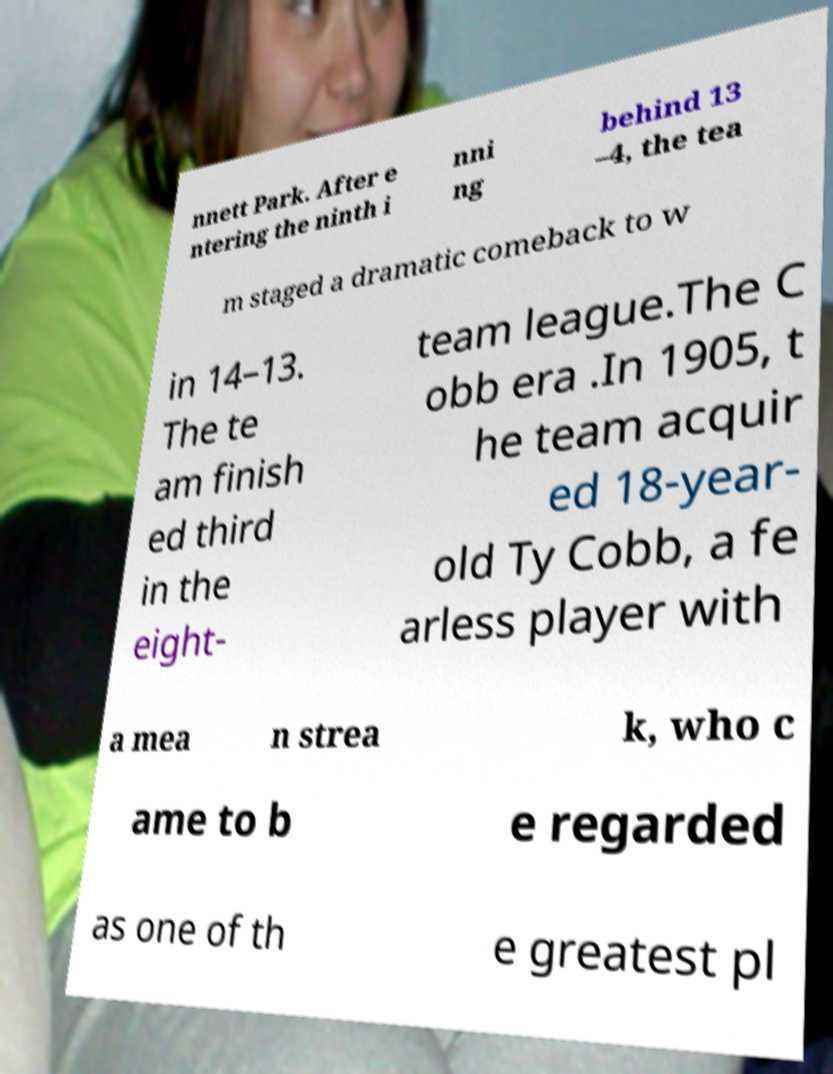There's text embedded in this image that I need extracted. Can you transcribe it verbatim? nnett Park. After e ntering the ninth i nni ng behind 13 –4, the tea m staged a dramatic comeback to w in 14–13. The te am finish ed third in the eight- team league.The C obb era .In 1905, t he team acquir ed 18-year- old Ty Cobb, a fe arless player with a mea n strea k, who c ame to b e regarded as one of th e greatest pl 